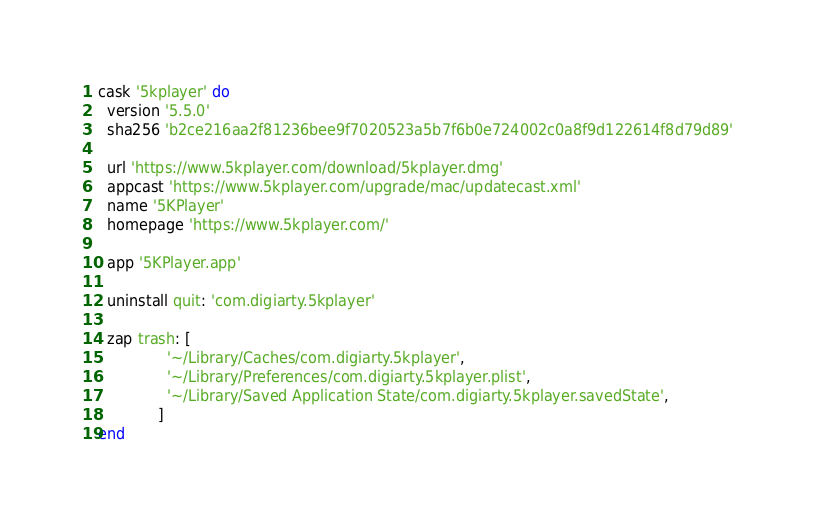<code> <loc_0><loc_0><loc_500><loc_500><_Ruby_>cask '5kplayer' do
  version '5.5.0'
  sha256 'b2ce216aa2f81236bee9f7020523a5b7f6b0e724002c0a8f9d122614f8d79d89'

  url 'https://www.5kplayer.com/download/5kplayer.dmg'
  appcast 'https://www.5kplayer.com/upgrade/mac/updatecast.xml'
  name '5KPlayer'
  homepage 'https://www.5kplayer.com/'

  app '5KPlayer.app'

  uninstall quit: 'com.digiarty.5kplayer'

  zap trash: [
               '~/Library/Caches/com.digiarty.5kplayer',
               '~/Library/Preferences/com.digiarty.5kplayer.plist',
               '~/Library/Saved Application State/com.digiarty.5kplayer.savedState',
             ]
end
</code> 